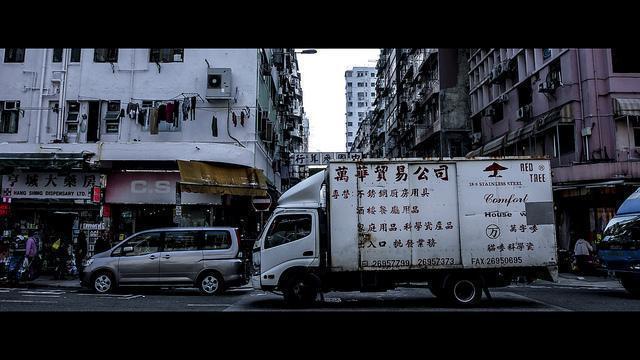Why does the large truck stop here?
Choose the correct response and explain in the format: 'Answer: answer
Rationale: rationale.'
Options: Fixing vehicle, traffic, truck broken, to advertise. Answer: traffic.
Rationale: The scene depicts heavy traffic so it's easy to discern the answer. 